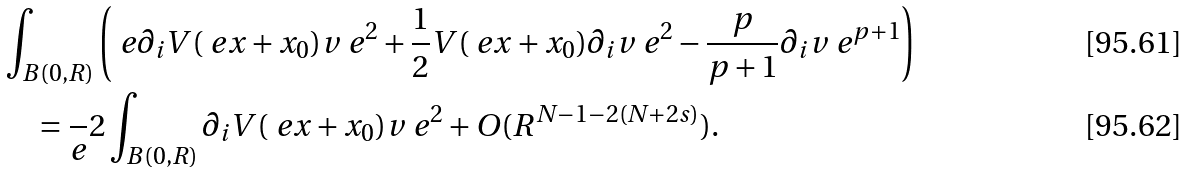<formula> <loc_0><loc_0><loc_500><loc_500>& \int _ { B ( 0 , R ) } \left ( \ e \partial _ { i } V ( \ e x + x _ { 0 } ) v _ { \ } e ^ { 2 } + \frac { 1 } { 2 } V ( \ e x + x _ { 0 } ) \partial _ { i } v _ { \ } e ^ { 2 } - \frac { p } { p + 1 } \partial _ { i } v _ { \ } e ^ { p + 1 } \right ) \\ & \quad = \frac { \ } { e } 2 \int _ { B ( 0 , R ) } \partial _ { i } V ( \ e x + x _ { 0 } ) v _ { \ } e ^ { 2 } + O ( R ^ { N - 1 - 2 ( N + 2 s ) } ) .</formula> 